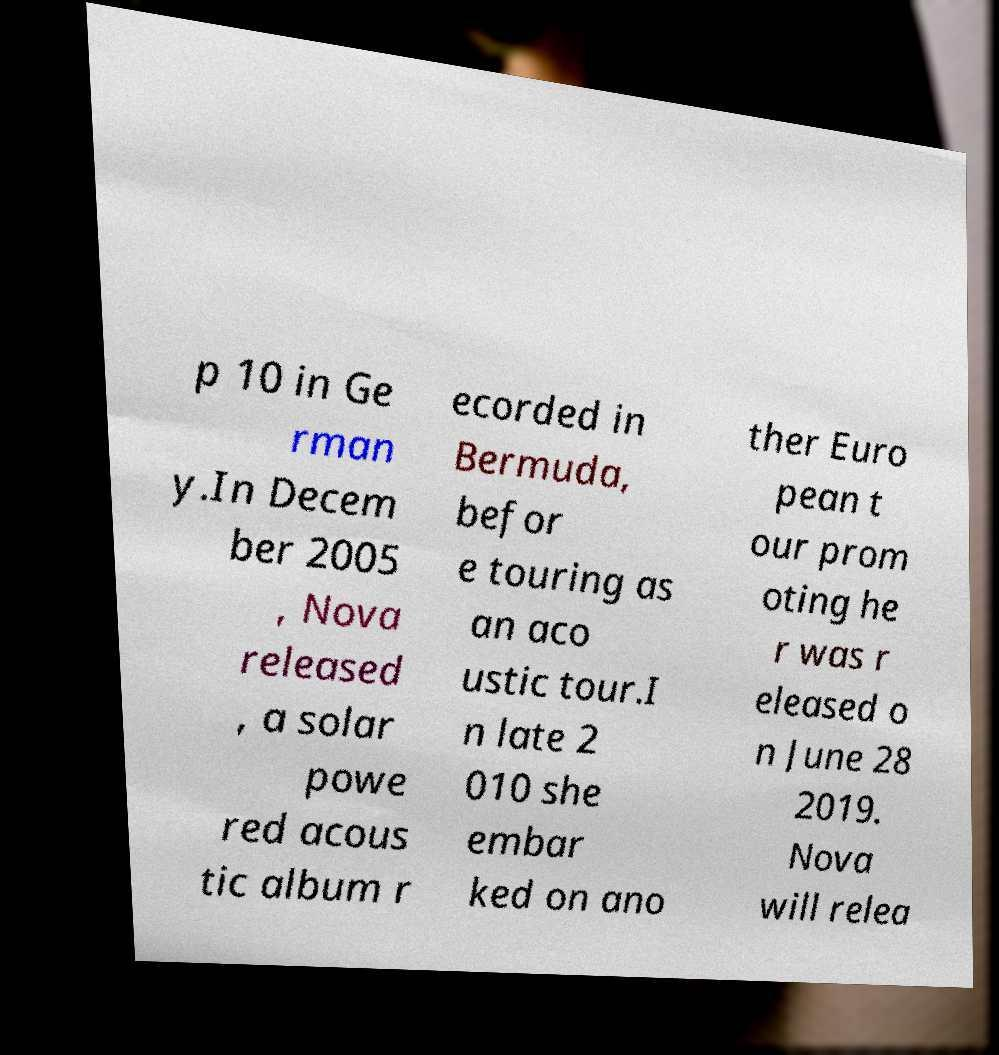Please identify and transcribe the text found in this image. p 10 in Ge rman y.In Decem ber 2005 , Nova released , a solar powe red acous tic album r ecorded in Bermuda, befor e touring as an aco ustic tour.I n late 2 010 she embar ked on ano ther Euro pean t our prom oting he r was r eleased o n June 28 2019. Nova will relea 